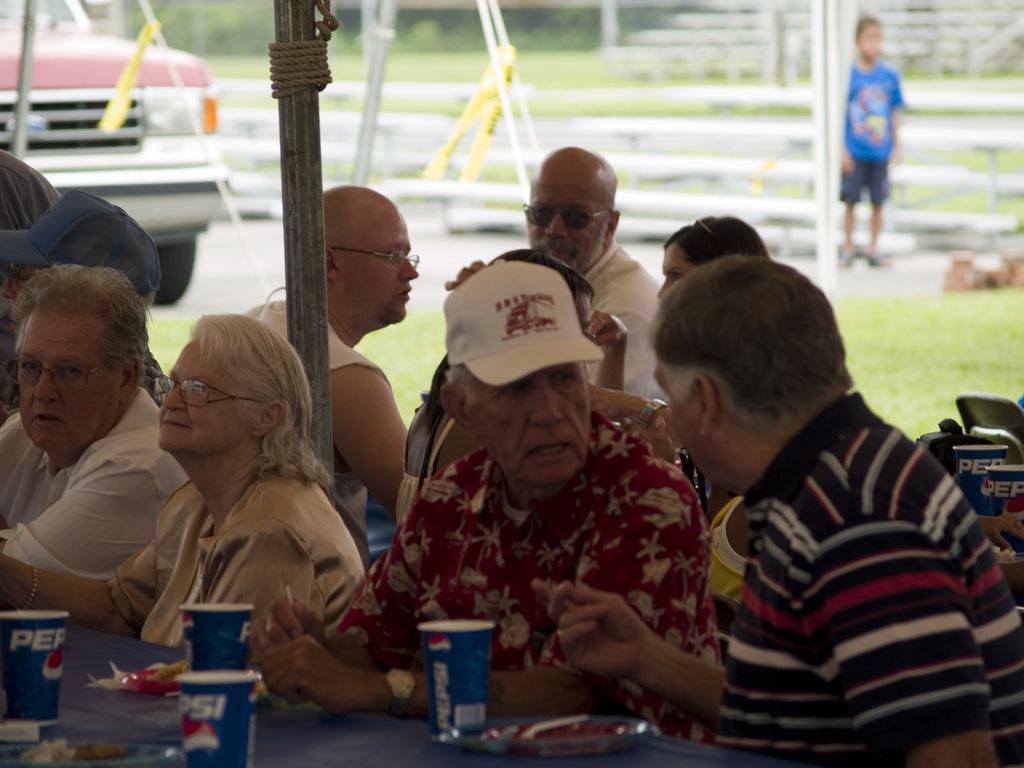Describe this image in one or two sentences. In this picture we can see a group of people sitting. At the bottom of the image, it looks like a table and on the table there are paper cups, plates and some objects. On the right side of the image, there are two other paper cups and a chair. Behind the people there is a pole, rope, a vehicle, grass, a kid is standing and some blurred objects. 